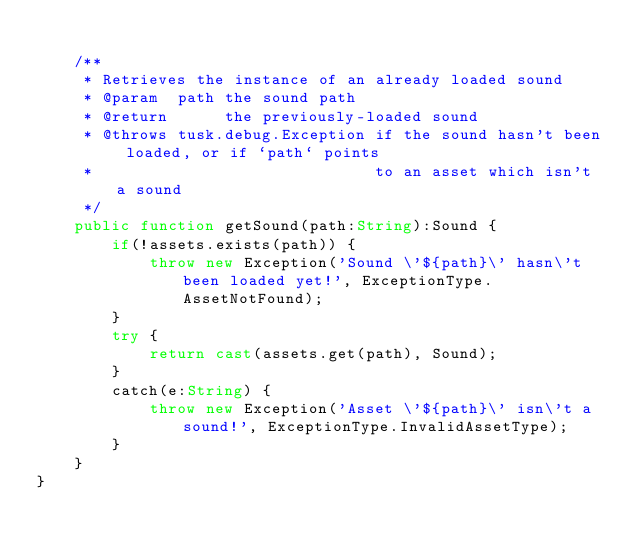<code> <loc_0><loc_0><loc_500><loc_500><_Haxe_>
	/**
	 * Retrieves the instance of an already loaded sound
	 * @param  path the sound path
	 * @return      the previously-loaded sound
	 * @throws tusk.debug.Exception if the sound hasn't been loaded, or if `path` points
	 *                              to an asset which isn't a sound
	 */
	public function getSound(path:String):Sound {
		if(!assets.exists(path)) {
			throw new Exception('Sound \'${path}\' hasn\'t been loaded yet!', ExceptionType.AssetNotFound);
		}
		try {
			return cast(assets.get(path), Sound);
		}
		catch(e:String) {
			throw new Exception('Asset \'${path}\' isn\'t a sound!', ExceptionType.InvalidAssetType);
		}
	}
}</code> 